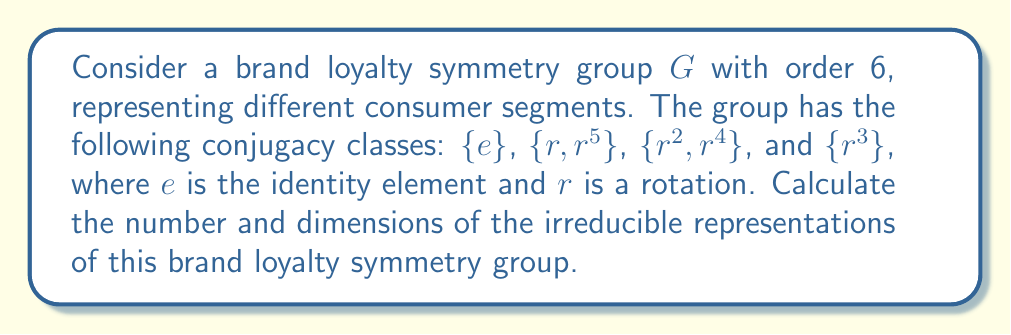Show me your answer to this math problem. To find the irreducible representations of the brand loyalty symmetry group, we'll follow these steps:

1. Determine the number of conjugacy classes:
   There are 4 conjugacy classes: $\{e\}$, $\{r, r^5\}$, $\{r^2, r^4\}$, and $\{r^3\}$.

2. Use the fact that the number of irreducible representations is equal to the number of conjugacy classes:
   There are 4 irreducible representations.

3. Apply the sum of squares formula:
   $$|G| = \sum_{i=1}^k d_i^2$$
   where $|G|$ is the order of the group (6 in this case), $k$ is the number of irreducible representations, and $d_i$ are the dimensions of the irreducible representations.

4. We know that the trivial representation always exists and has dimension 1. Let's call the other dimensions $x$, $y$, and $z$. We can set up the equation:
   $$6 = 1^2 + x^2 + y^2 + z^2$$

5. Given that dimensions must be positive integers, the only solution that satisfies this equation is:
   $$6 = 1^2 + 1^2 + 1^2 + 1^2$$

Therefore, all four irreducible representations have dimension 1.

This result aligns with consumer psychology principles, suggesting that brand loyalty segments in this model are distinct and cannot be further reduced, representing unique consumer profiles.
Answer: 4 irreducible representations, all of dimension 1 